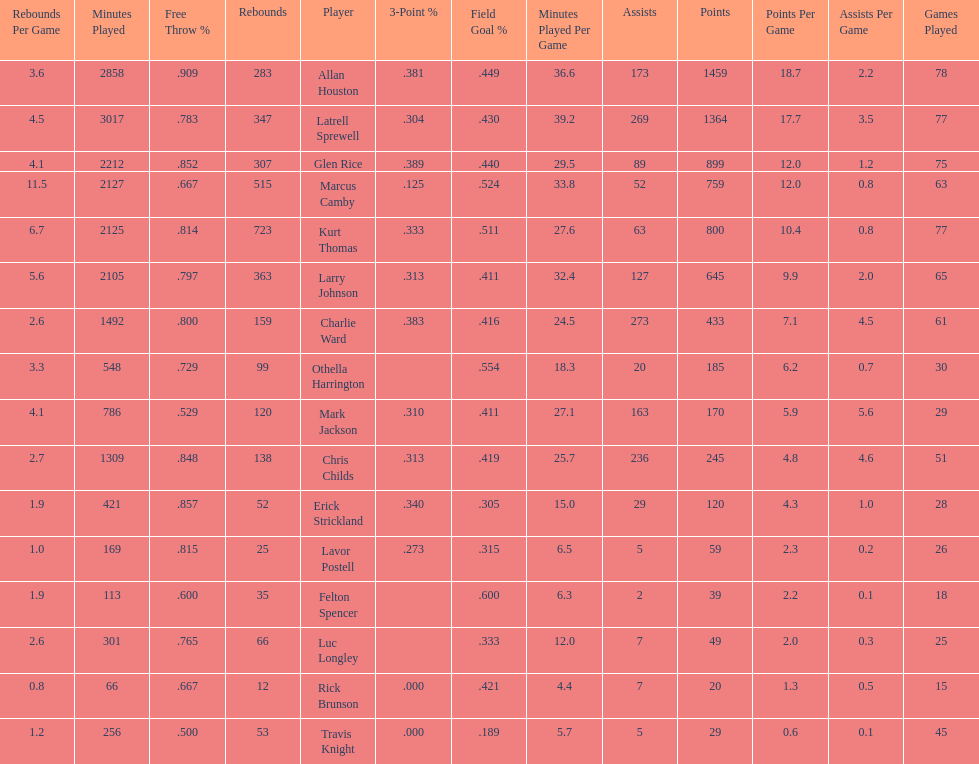How many games did larry johnson play? 65. 